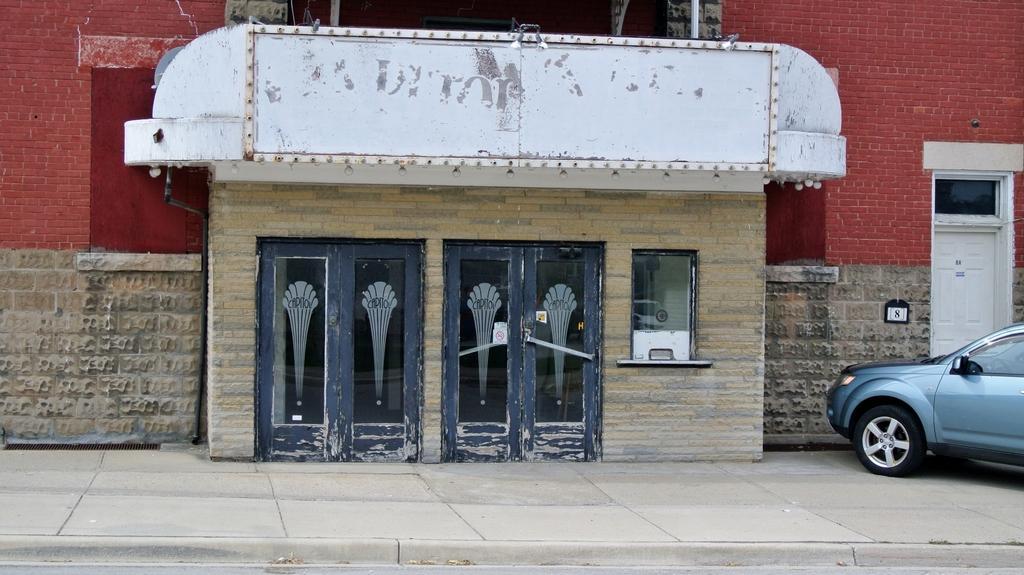Please provide a concise description of this image. In this image we can see a building with doors. Also there is a window. On the right side we can see a car. 